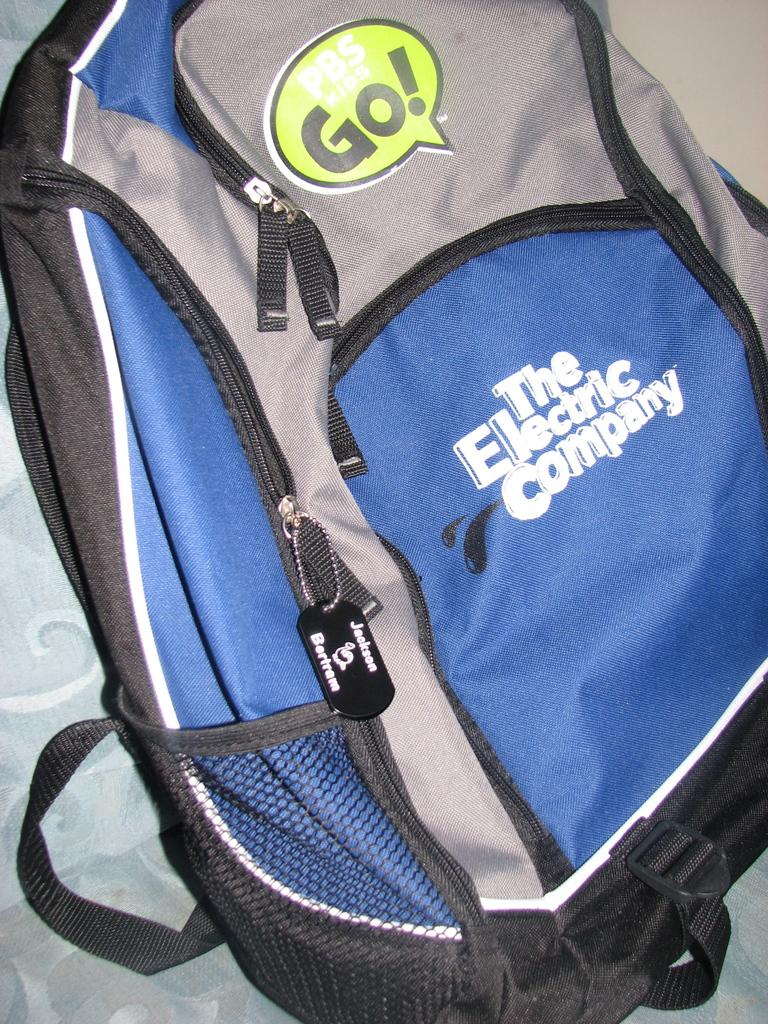What type of bag is in the image? There is a backpack bag in the image. What colors can be seen on the backpack bag? The backpack bag is grey and blue in color. What is written on the bag? The words "electric company" are written on the bag. How many zips does the bag have? The bag has two zips. What additional feature does the bag have? The bag has a water bottle sack. How many boys are carrying the backpack bag in the image? There is no boy present in the image; it only shows the backpack bag. What type of quiver is attached to the backpack bag? There is no quiver present in the image; the backpack bag only has a water bottle sack. 